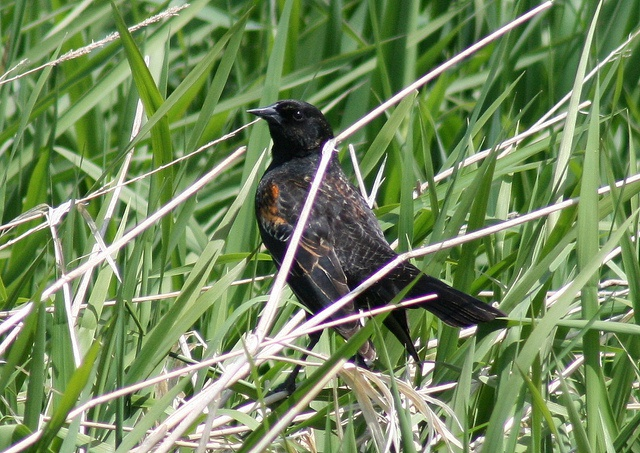Describe the objects in this image and their specific colors. I can see a bird in green, black, gray, white, and darkgray tones in this image. 